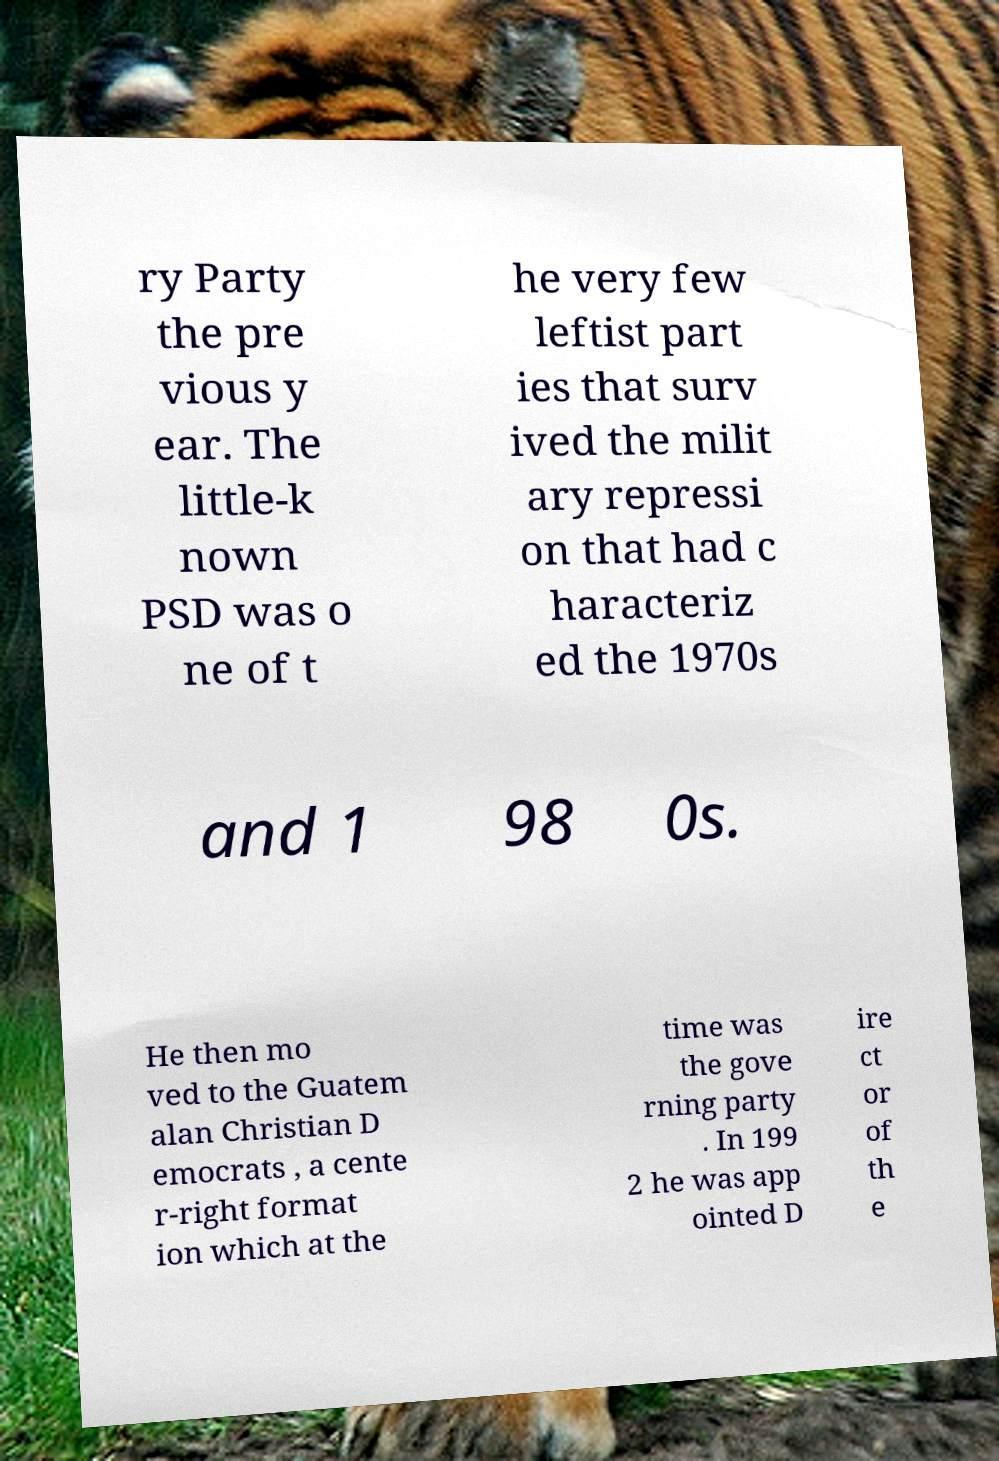Please read and relay the text visible in this image. What does it say? ry Party the pre vious y ear. The little-k nown PSD was o ne of t he very few leftist part ies that surv ived the milit ary repressi on that had c haracteriz ed the 1970s and 1 98 0s. He then mo ved to the Guatem alan Christian D emocrats , a cente r-right format ion which at the time was the gove rning party . In 199 2 he was app ointed D ire ct or of th e 